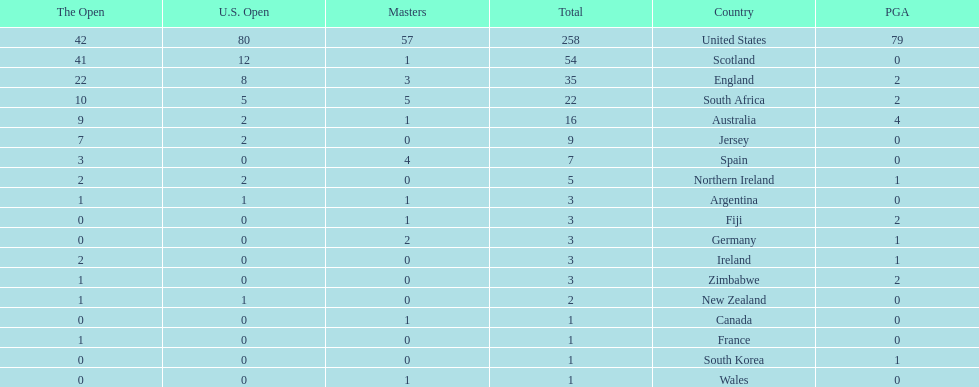Would you be able to parse every entry in this table? {'header': ['The Open', 'U.S. Open', 'Masters', 'Total', 'Country', 'PGA'], 'rows': [['42', '80', '57', '258', 'United States', '79'], ['41', '12', '1', '54', 'Scotland', '0'], ['22', '8', '3', '35', 'England', '2'], ['10', '5', '5', '22', 'South Africa', '2'], ['9', '2', '1', '16', 'Australia', '4'], ['7', '2', '0', '9', 'Jersey', '0'], ['3', '0', '4', '7', 'Spain', '0'], ['2', '2', '0', '5', 'Northern Ireland', '1'], ['1', '1', '1', '3', 'Argentina', '0'], ['0', '0', '1', '3', 'Fiji', '2'], ['0', '0', '2', '3', 'Germany', '1'], ['2', '0', '0', '3', 'Ireland', '1'], ['1', '0', '0', '3', 'Zimbabwe', '2'], ['1', '1', '0', '2', 'New Zealand', '0'], ['0', '0', '1', '1', 'Canada', '0'], ['1', '0', '0', '1', 'France', '0'], ['0', '0', '0', '1', 'South Korea', '1'], ['0', '0', '1', '1', 'Wales', '0']]} How many total championships does spain have? 7. 